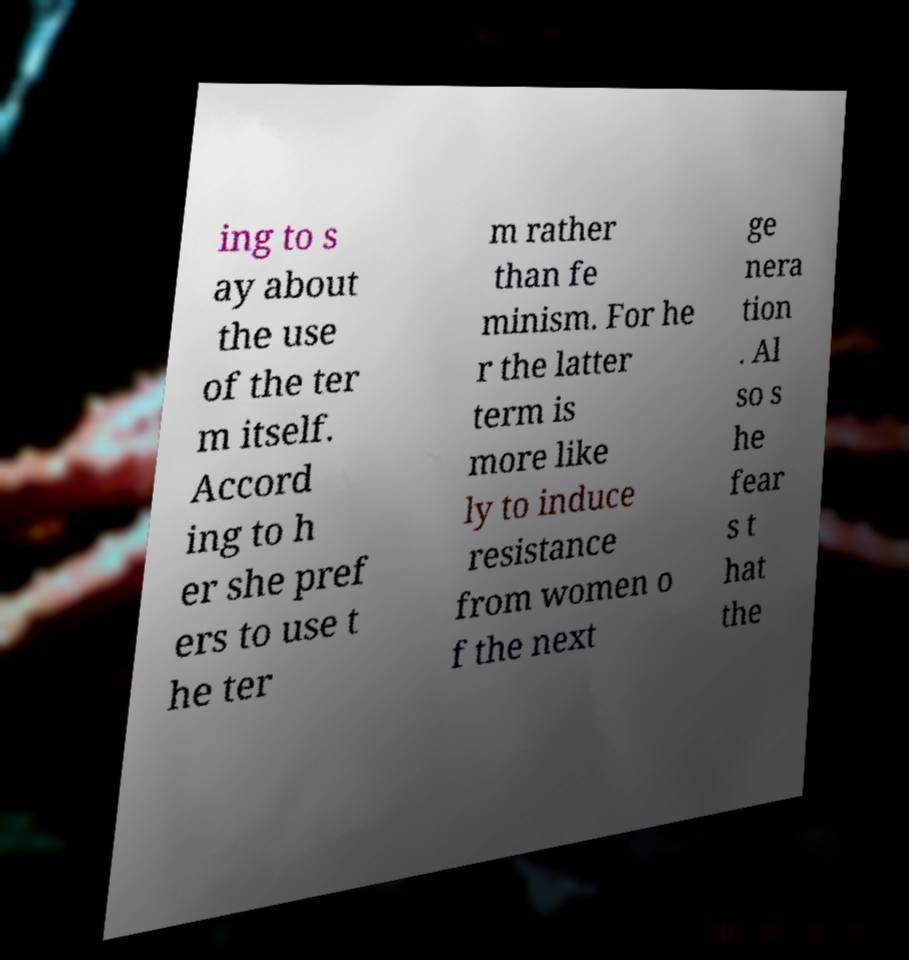Please identify and transcribe the text found in this image. ing to s ay about the use of the ter m itself. Accord ing to h er she pref ers to use t he ter m rather than fe minism. For he r the latter term is more like ly to induce resistance from women o f the next ge nera tion . Al so s he fear s t hat the 